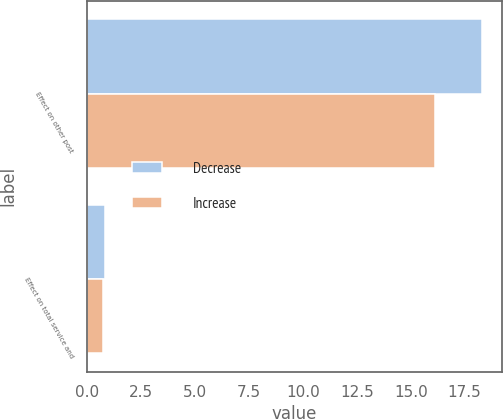Convert chart. <chart><loc_0><loc_0><loc_500><loc_500><stacked_bar_chart><ecel><fcel>Effect on other post<fcel>Effect on total service and<nl><fcel>Decrease<fcel>18.3<fcel>0.8<nl><fcel>Increase<fcel>16.1<fcel>0.7<nl></chart> 